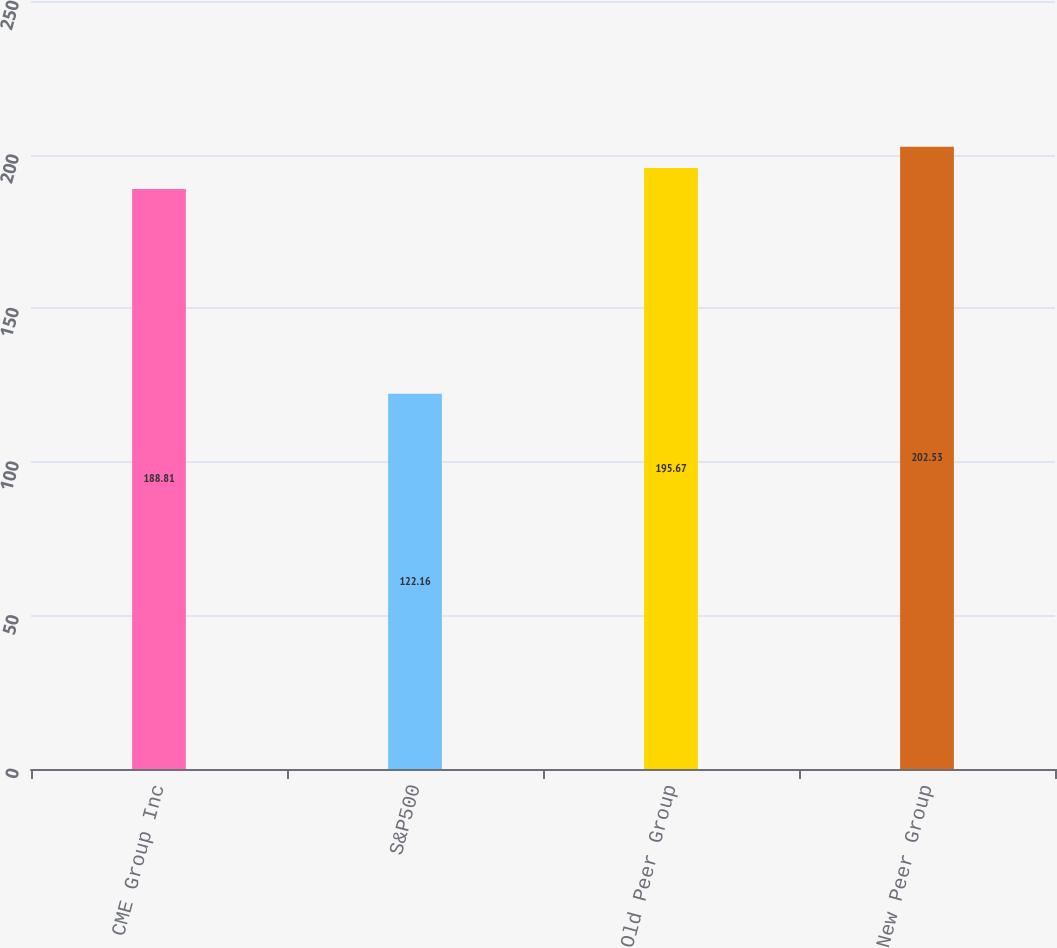<chart> <loc_0><loc_0><loc_500><loc_500><bar_chart><fcel>CME Group Inc<fcel>S&P500<fcel>Old Peer Group<fcel>New Peer Group<nl><fcel>188.81<fcel>122.16<fcel>195.67<fcel>202.53<nl></chart> 